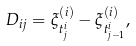Convert formula to latex. <formula><loc_0><loc_0><loc_500><loc_500>\ D _ { i j } = \xi ^ { ( i ) } _ { t ^ { i } _ { j } } - \xi ^ { ( i ) } _ { t ^ { i } _ { j - 1 } } ,</formula> 